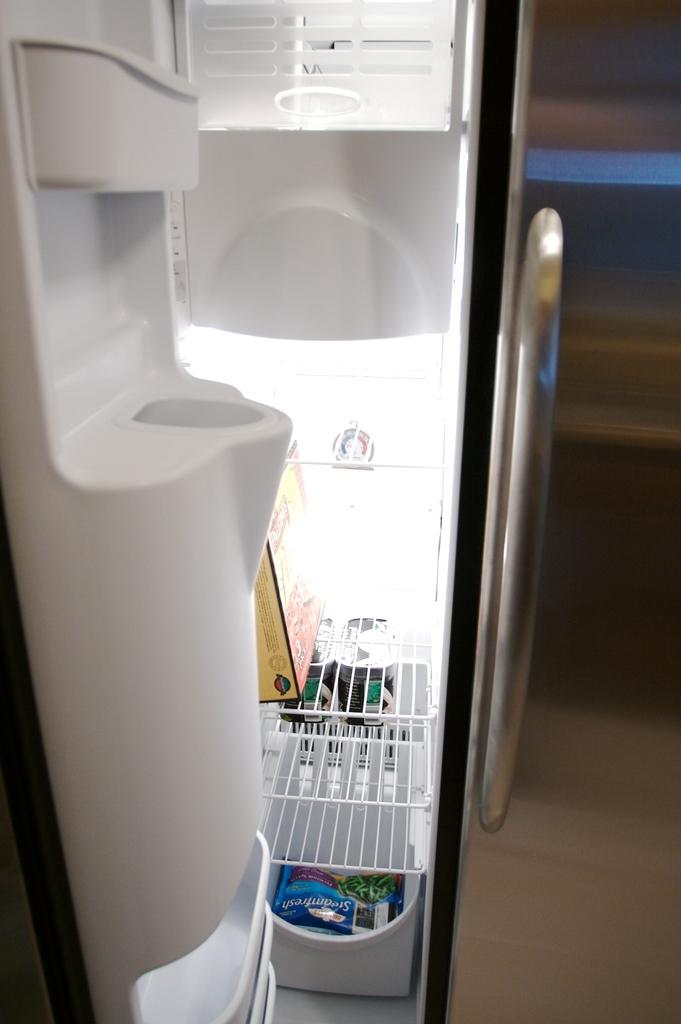What brand of vegetables?
Offer a very short reply. Unanswerable. 